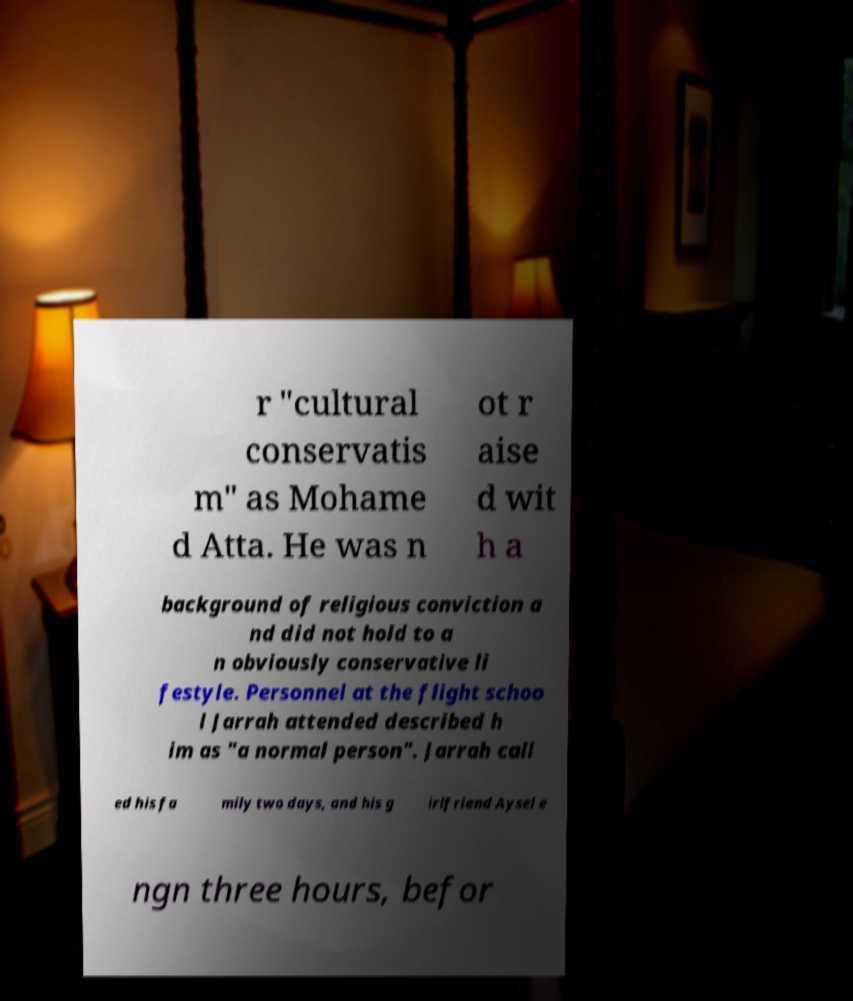Can you accurately transcribe the text from the provided image for me? r "cultural conservatis m" as Mohame d Atta. He was n ot r aise d wit h a background of religious conviction a nd did not hold to a n obviously conservative li festyle. Personnel at the flight schoo l Jarrah attended described h im as "a normal person". Jarrah call ed his fa mily two days, and his g irlfriend Aysel e ngn three hours, befor 